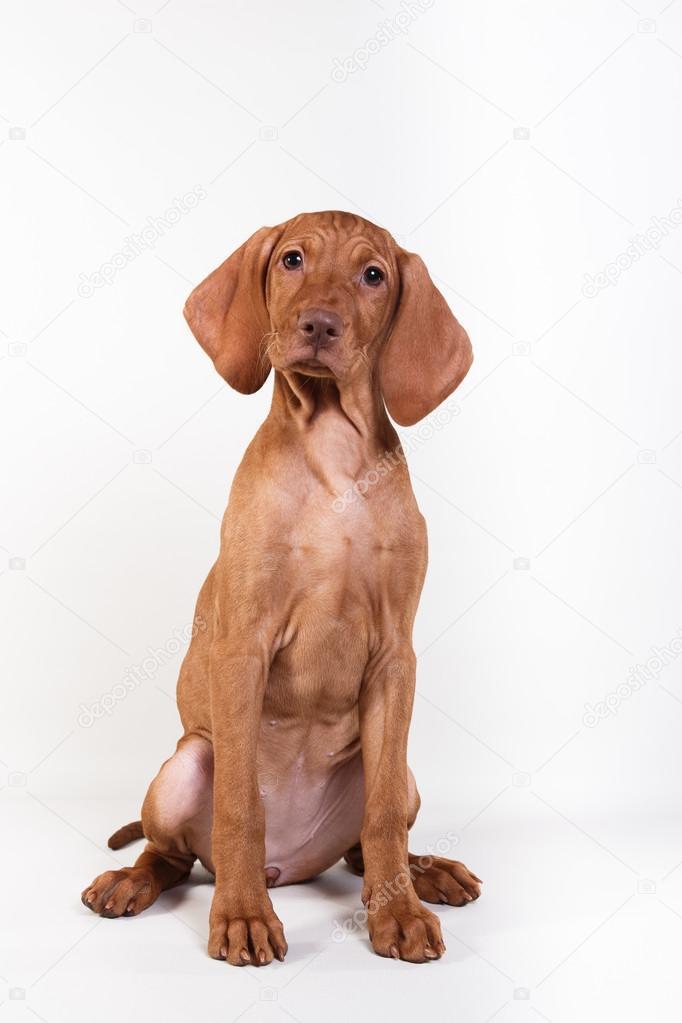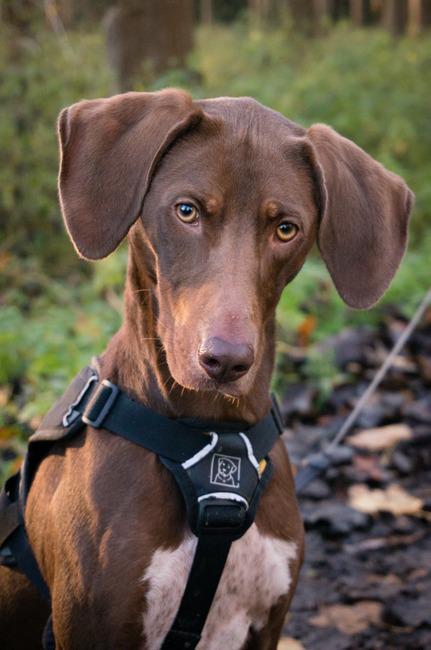The first image is the image on the left, the second image is the image on the right. For the images shown, is this caption "The dog on the left is gazing leftward, and the dog on the right stands in profile with its body turned rightward." true? Answer yes or no. No. The first image is the image on the left, the second image is the image on the right. Given the left and right images, does the statement "At least one dog is sitting." hold true? Answer yes or no. Yes. 